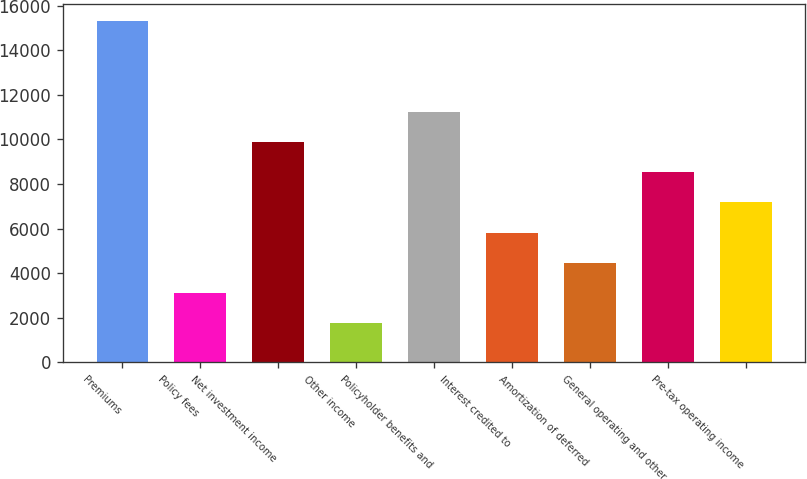Convert chart to OTSL. <chart><loc_0><loc_0><loc_500><loc_500><bar_chart><fcel>Premiums<fcel>Policy fees<fcel>Net investment income<fcel>Other income<fcel>Policyholder benefits and<fcel>Interest credited to<fcel>Amortization of deferred<fcel>General operating and other<fcel>Pre-tax operating income<nl><fcel>15302<fcel>3108.8<fcel>9882.8<fcel>1754<fcel>11237.6<fcel>5818.4<fcel>4463.6<fcel>8528<fcel>7173.2<nl></chart> 